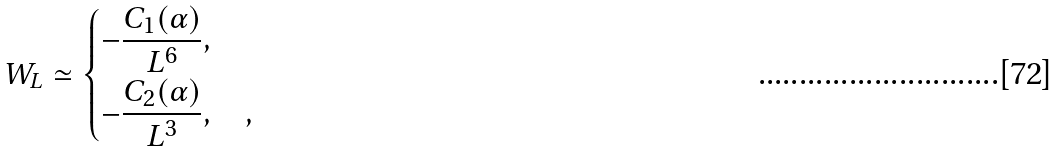Convert formula to latex. <formula><loc_0><loc_0><loc_500><loc_500>W _ { L } \simeq \begin{dcases} - \frac { C _ { 1 } ( \alpha ) } { L ^ { 6 } } , & \\ - \frac { C _ { 2 } ( \alpha ) } { L ^ { 3 } } , & , \end{dcases}</formula> 